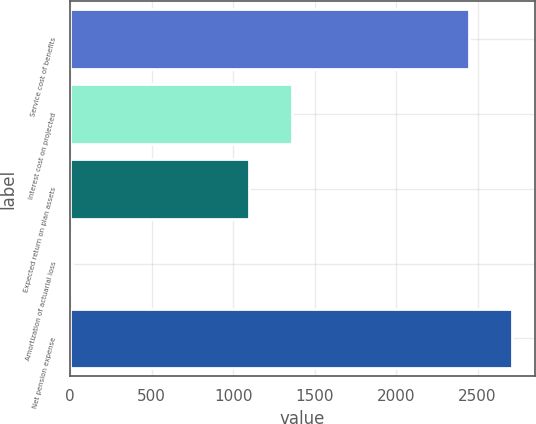Convert chart. <chart><loc_0><loc_0><loc_500><loc_500><bar_chart><fcel>Service cost of benefits<fcel>Interest cost on projected<fcel>Expected return on plan assets<fcel>Amortization of actuarial loss<fcel>Net pension expense<nl><fcel>2450<fcel>1358.1<fcel>1094<fcel>13<fcel>2714.1<nl></chart> 